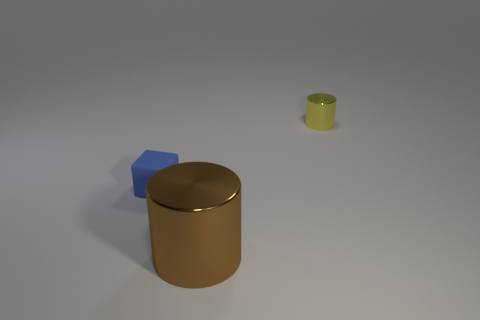Add 3 small cyan metallic cylinders. How many objects exist? 6 Subtract all blocks. How many objects are left? 2 Subtract all small metallic things. Subtract all tiny blue blocks. How many objects are left? 1 Add 3 rubber cubes. How many rubber cubes are left? 4 Add 2 small yellow shiny cylinders. How many small yellow shiny cylinders exist? 3 Subtract 0 gray balls. How many objects are left? 3 